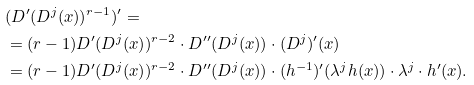Convert formula to latex. <formula><loc_0><loc_0><loc_500><loc_500>& ( D ^ { \prime } ( D ^ { j } ( x ) ) ^ { r - 1 } ) ^ { \prime } = \\ & = ( r - 1 ) D ^ { \prime } ( D ^ { j } ( x ) ) ^ { r - 2 } \cdot D ^ { \prime \prime } ( D ^ { j } ( x ) ) \cdot ( D ^ { j } ) ^ { \prime } ( x ) \\ & = ( r - 1 ) D ^ { \prime } ( D ^ { j } ( x ) ) ^ { r - 2 } \cdot D ^ { \prime \prime } ( D ^ { j } ( x ) ) \cdot ( h ^ { - 1 } ) ^ { \prime } ( \lambda ^ { j } h ( x ) ) \cdot \lambda ^ { j } \cdot h ^ { \prime } ( x ) .</formula> 